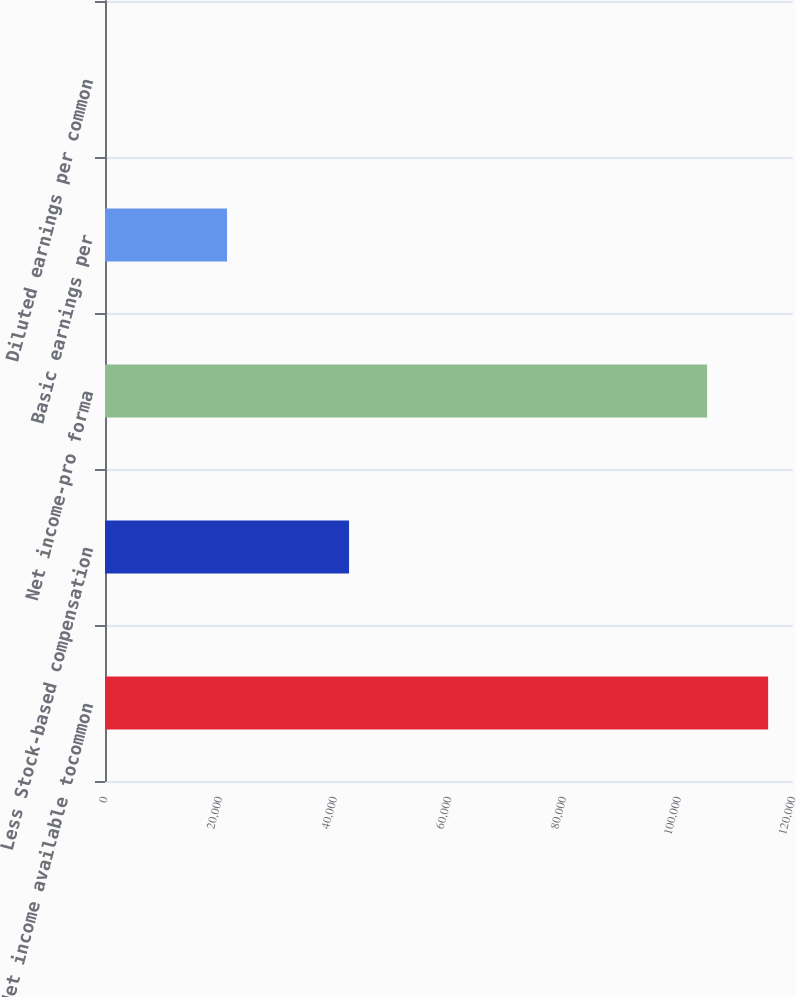Convert chart to OTSL. <chart><loc_0><loc_0><loc_500><loc_500><bar_chart><fcel>Net income available tocommon<fcel>Less Stock-based compensation<fcel>Net income-pro forma<fcel>Basic earnings per<fcel>Diluted earnings per common<nl><fcel>115661<fcel>42567.8<fcel>105019<fcel>21284.4<fcel>0.97<nl></chart> 